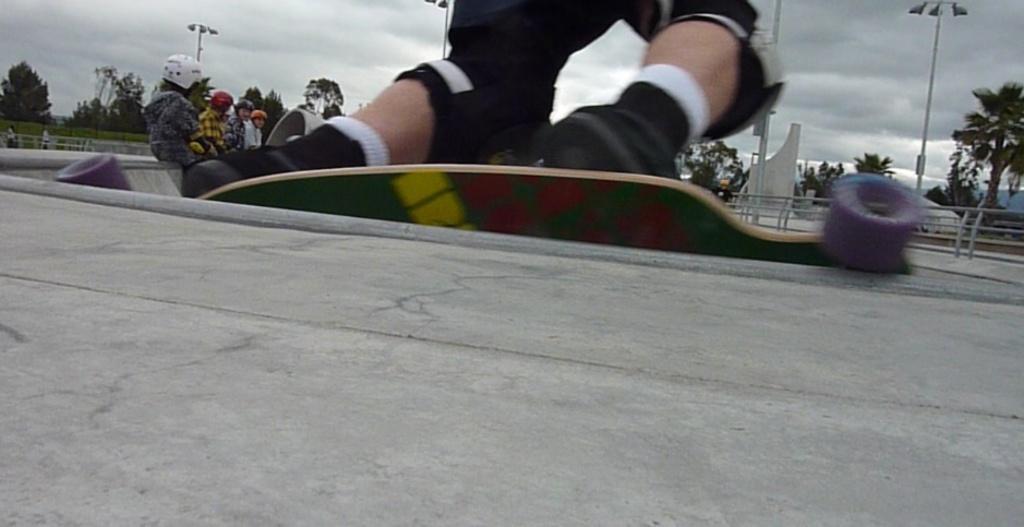Please provide a concise description of this image. This picture is clicked outside. In the foreground we can see a person seems to be skating with the skateboard. In the background we can see the sky, lamp posts, trees, green grass, group of people and many other items. 